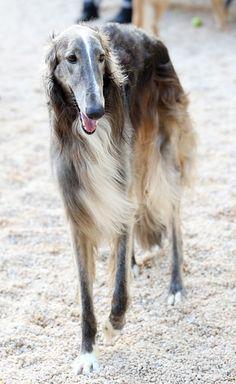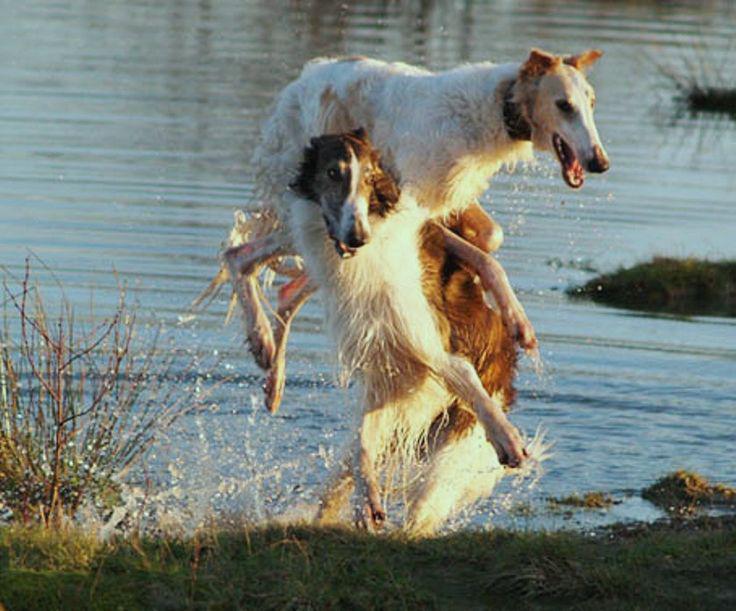The first image is the image on the left, the second image is the image on the right. Evaluate the accuracy of this statement regarding the images: "Two dogs are playing with each other in one image.". Is it true? Answer yes or no. Yes. 